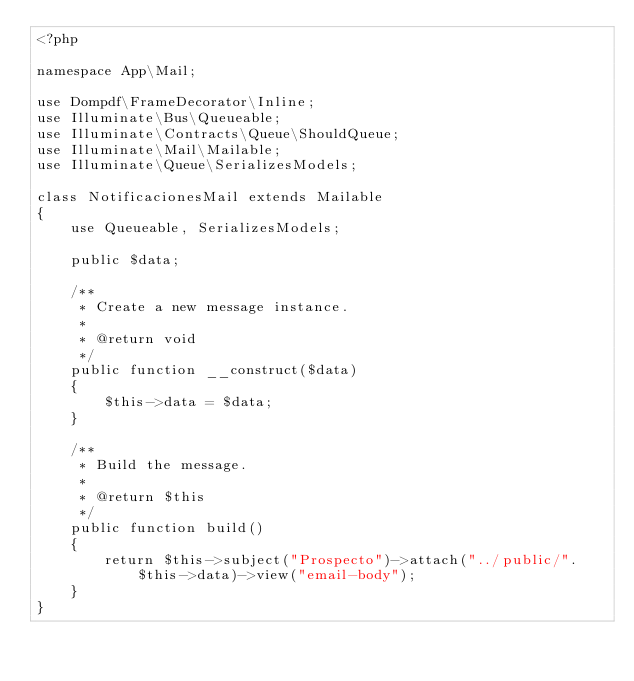<code> <loc_0><loc_0><loc_500><loc_500><_PHP_><?php

namespace App\Mail;

use Dompdf\FrameDecorator\Inline;
use Illuminate\Bus\Queueable;
use Illuminate\Contracts\Queue\ShouldQueue;
use Illuminate\Mail\Mailable;
use Illuminate\Queue\SerializesModels;

class NotificacionesMail extends Mailable
{
    use Queueable, SerializesModels;

    public $data;

    /**
     * Create a new message instance.
     *
     * @return void
     */
    public function __construct($data)
    {
        $this->data = $data;
    }

    /**
     * Build the message.
     *
     * @return $this
     */
    public function build()
    {   
        return $this->subject("Prospecto")->attach("../public/".$this->data)->view("email-body");
    }
}
</code> 